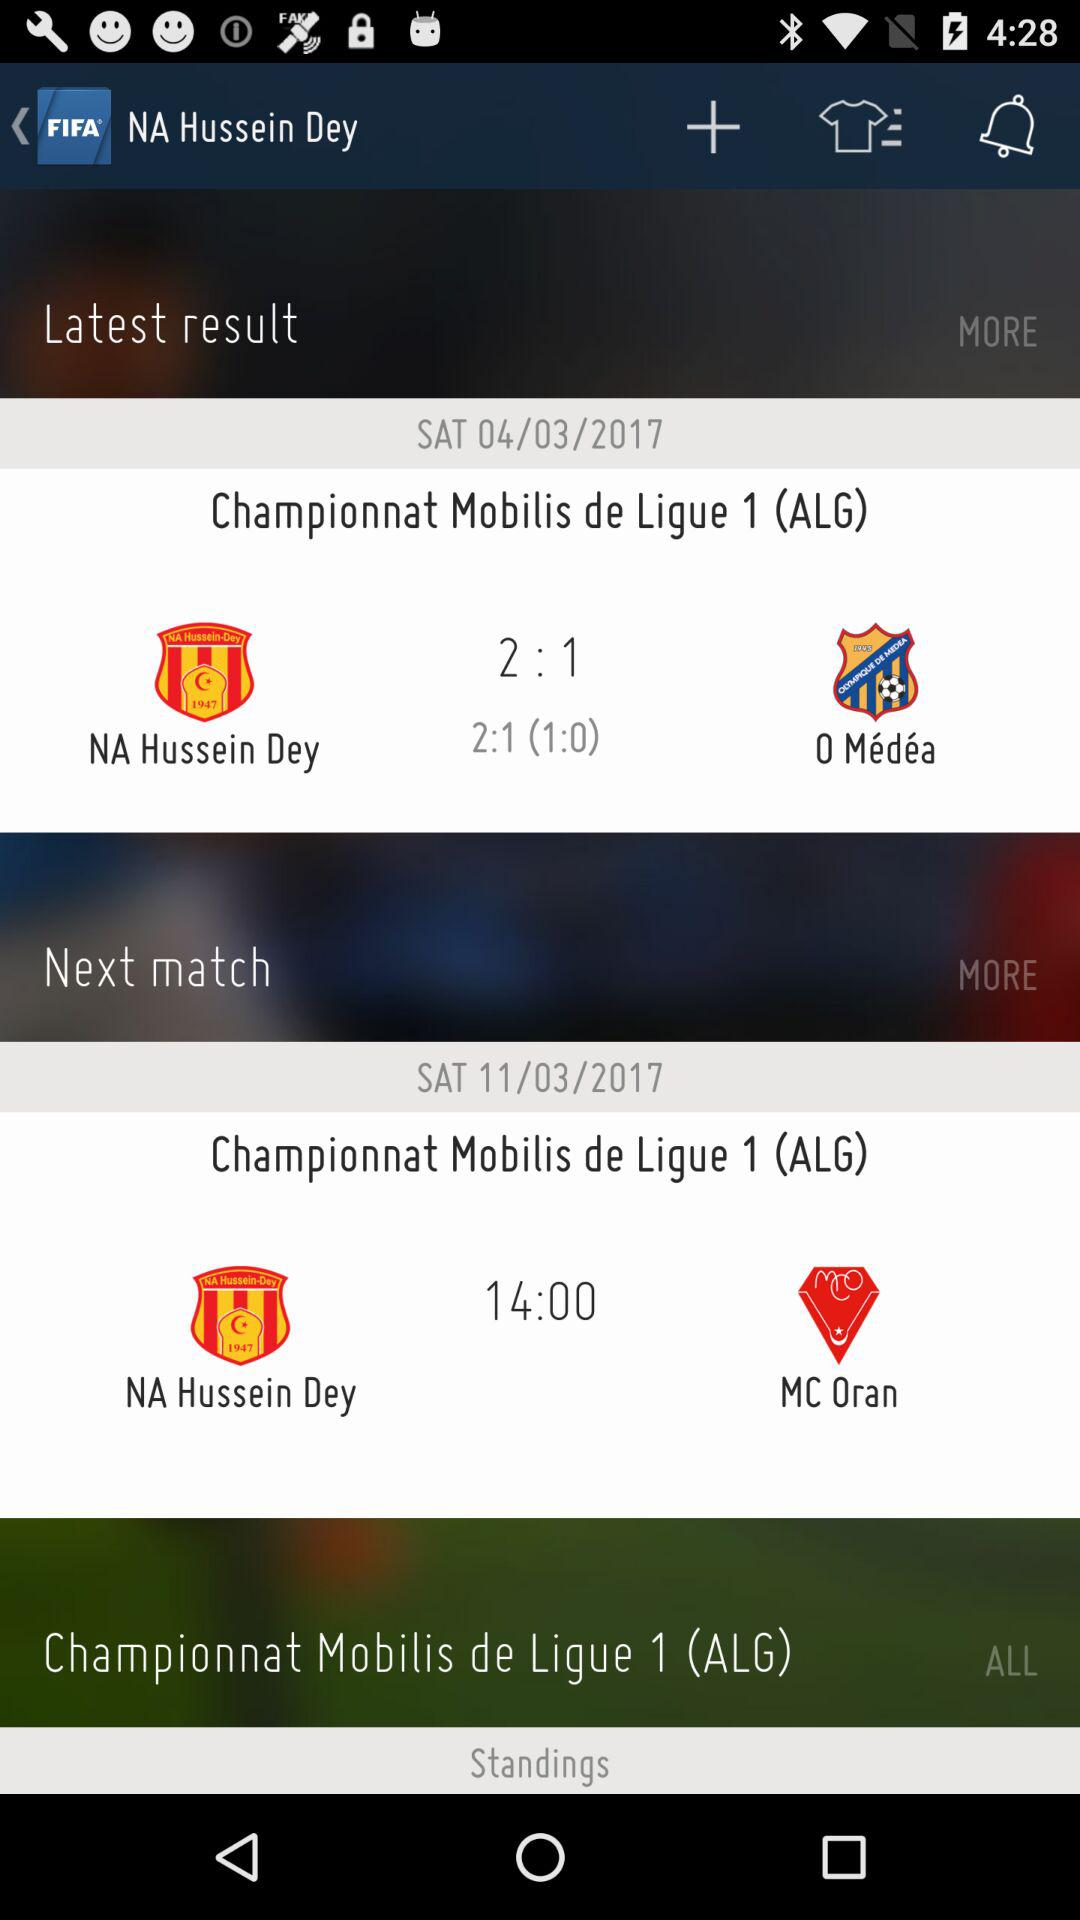When will the match between "NA Hussein Dey" and "MC Oran" be held? The match between "NA Hussein Dey" and "MC Oran" will be held on Saturday, March 11, 2017. 